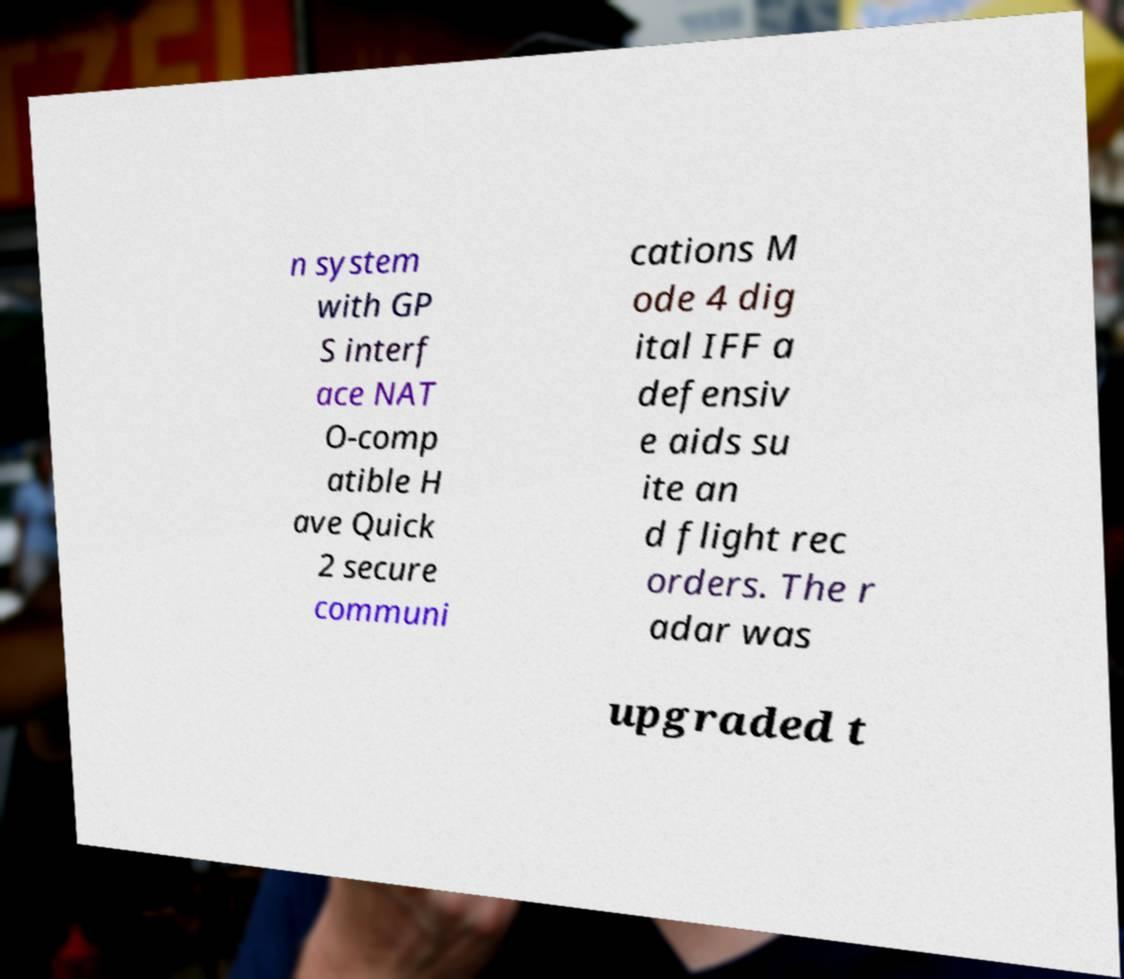Can you accurately transcribe the text from the provided image for me? n system with GP S interf ace NAT O-comp atible H ave Quick 2 secure communi cations M ode 4 dig ital IFF a defensiv e aids su ite an d flight rec orders. The r adar was upgraded t 